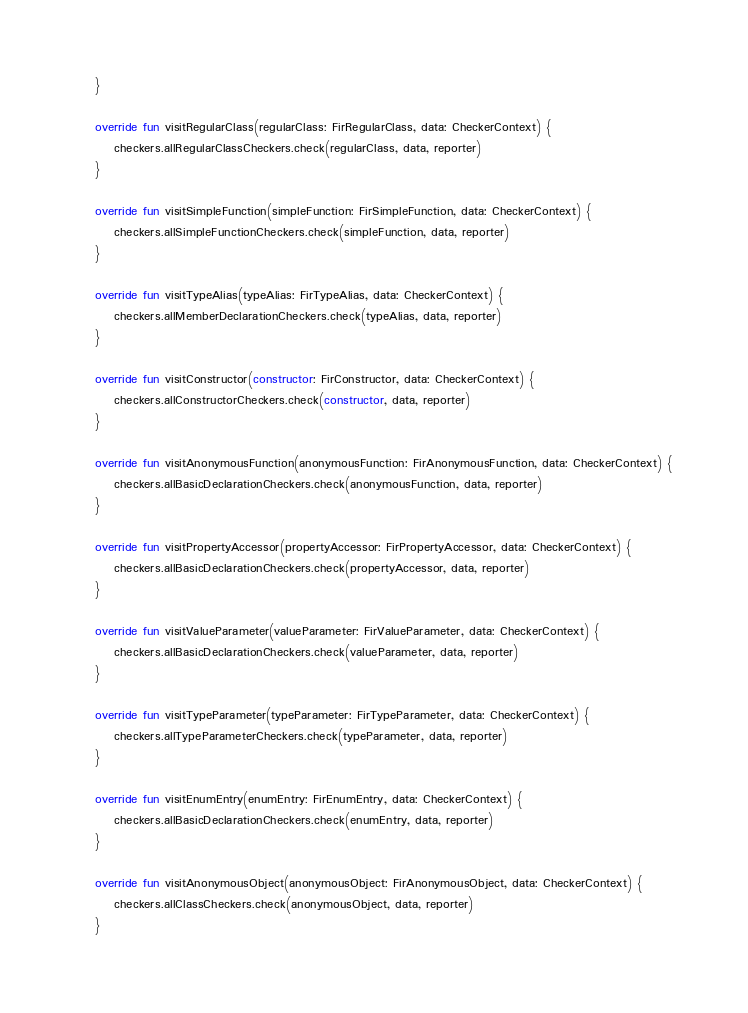<code> <loc_0><loc_0><loc_500><loc_500><_Kotlin_>    }

    override fun visitRegularClass(regularClass: FirRegularClass, data: CheckerContext) {
        checkers.allRegularClassCheckers.check(regularClass, data, reporter)
    }

    override fun visitSimpleFunction(simpleFunction: FirSimpleFunction, data: CheckerContext) {
        checkers.allSimpleFunctionCheckers.check(simpleFunction, data, reporter)
    }

    override fun visitTypeAlias(typeAlias: FirTypeAlias, data: CheckerContext) {
        checkers.allMemberDeclarationCheckers.check(typeAlias, data, reporter)
    }

    override fun visitConstructor(constructor: FirConstructor, data: CheckerContext) {
        checkers.allConstructorCheckers.check(constructor, data, reporter)
    }

    override fun visitAnonymousFunction(anonymousFunction: FirAnonymousFunction, data: CheckerContext) {
        checkers.allBasicDeclarationCheckers.check(anonymousFunction, data, reporter)
    }

    override fun visitPropertyAccessor(propertyAccessor: FirPropertyAccessor, data: CheckerContext) {
        checkers.allBasicDeclarationCheckers.check(propertyAccessor, data, reporter)
    }

    override fun visitValueParameter(valueParameter: FirValueParameter, data: CheckerContext) {
        checkers.allBasicDeclarationCheckers.check(valueParameter, data, reporter)
    }

    override fun visitTypeParameter(typeParameter: FirTypeParameter, data: CheckerContext) {
        checkers.allTypeParameterCheckers.check(typeParameter, data, reporter)
    }

    override fun visitEnumEntry(enumEntry: FirEnumEntry, data: CheckerContext) {
        checkers.allBasicDeclarationCheckers.check(enumEntry, data, reporter)
    }

    override fun visitAnonymousObject(anonymousObject: FirAnonymousObject, data: CheckerContext) {
        checkers.allClassCheckers.check(anonymousObject, data, reporter)
    }
</code> 